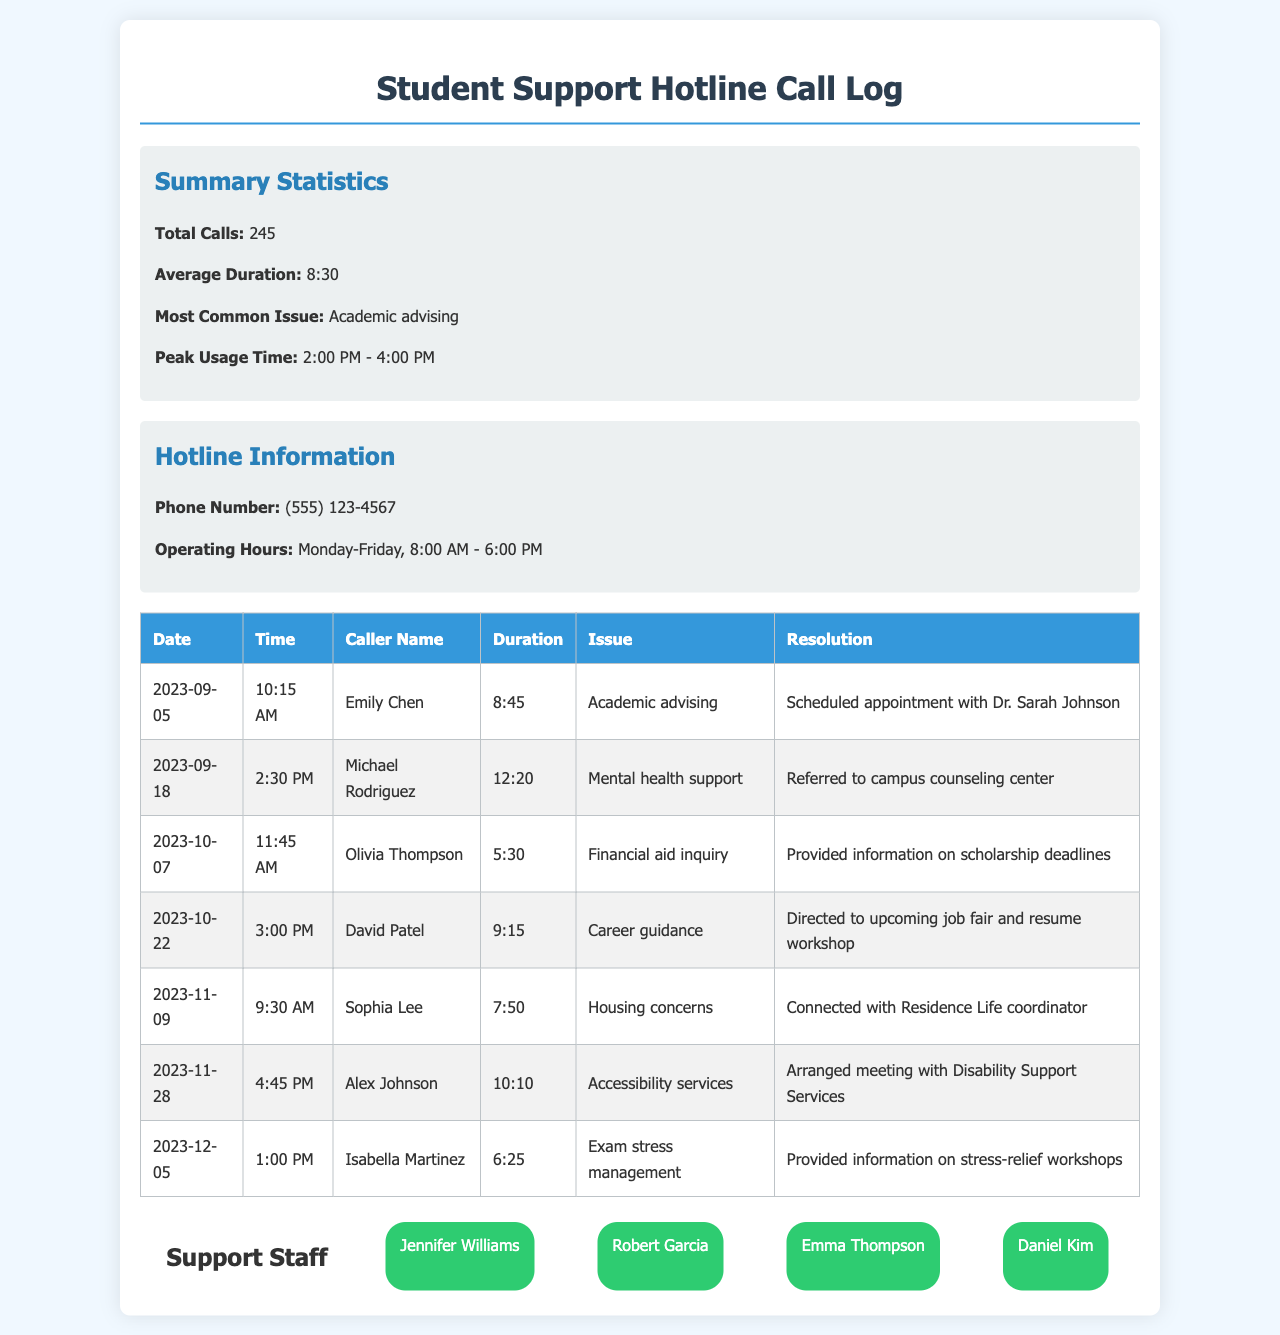What is the total number of calls? The total number of calls is provided in the summary section of the document.
Answer: 245 What is the average call duration? The average call duration is mentioned in the summary statistics.
Answer: 8:30 What was the most common issue reported? The most common issue is stated in the summary of the document.
Answer: Academic advising What time period had peak usage? The peak usage time is highlighted in the summary section.
Answer: 2:00 PM - 4:00 PM Who called on October 7th? The caller's name is listed in the table for the specified date.
Answer: Olivia Thompson How long did Alex Johnson's call last? The duration is provided in the call log table for Alex Johnson's call.
Answer: 10:10 What is the phone number for the hotline? The hotline phone number is detailed in the hotline information section.
Answer: (555) 123-4567 Which staff member is listed first? The order of staff members is shown in the support staff list.
Answer: Jennifer Williams Which issue was referred to the counseling center? The specific issue is available in the table associated with Michael Rodriguez's call.
Answer: Mental health support 